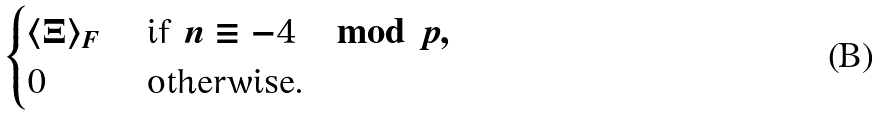<formula> <loc_0><loc_0><loc_500><loc_500>\begin{cases} \langle \Xi \rangle _ { F } & \text { if } n \equiv - 4 \mod p , \\ 0 & \text { otherwise.} \end{cases}</formula> 